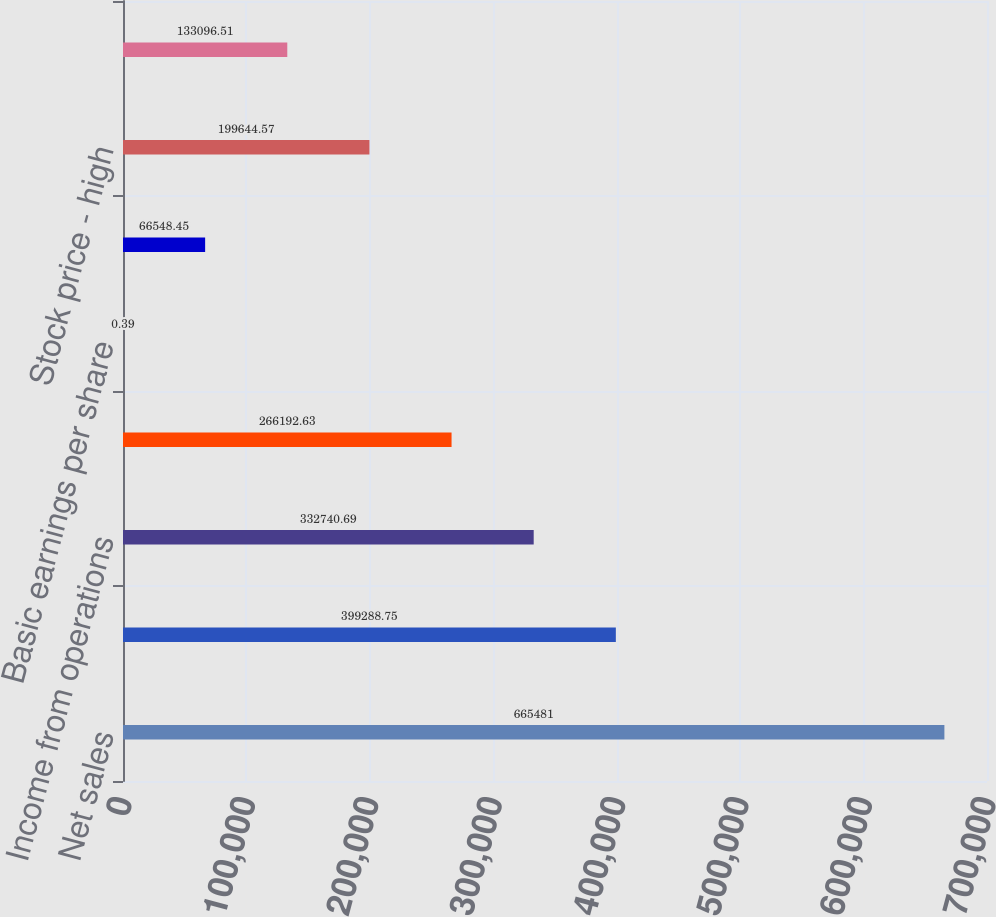Convert chart. <chart><loc_0><loc_0><loc_500><loc_500><bar_chart><fcel>Net sales<fcel>Gross profit<fcel>Income from operations<fcel>Net income<fcel>Basic earnings per share<fcel>Diluted earnings per share<fcel>Stock price - high<fcel>Stock price - low<nl><fcel>665481<fcel>399289<fcel>332741<fcel>266193<fcel>0.39<fcel>66548.4<fcel>199645<fcel>133097<nl></chart> 